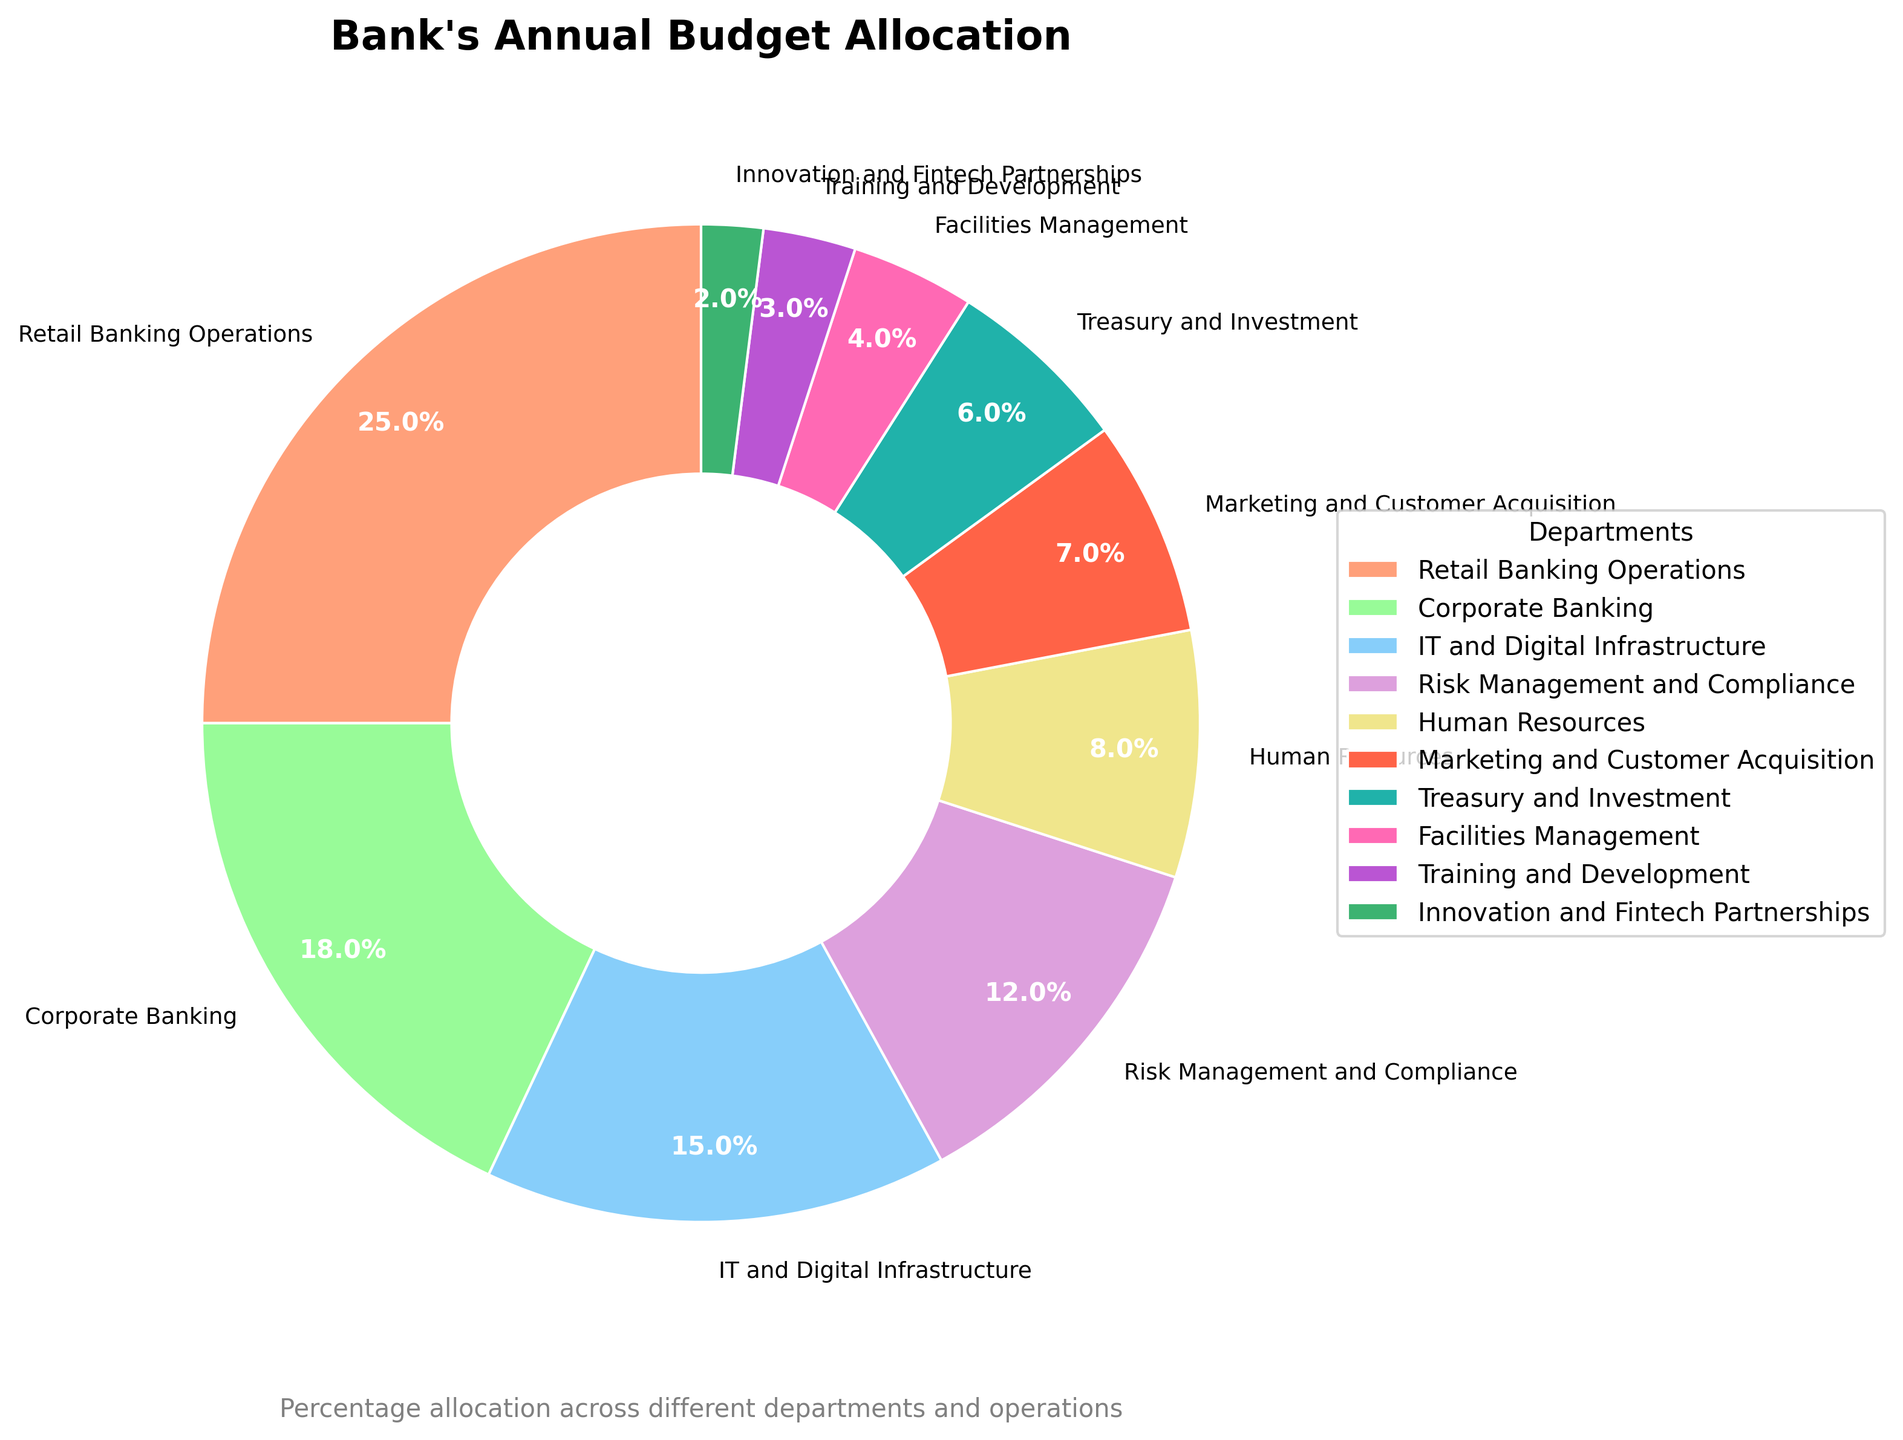What percentage of the budget is allocated to Marketing and Customer Acquisition? By looking at the pie chart, you can see the segment labeled "Marketing and Customer Acquisition". The percentage is displayed within or near the segment.
Answer: 7% Which department has the largest budget allocation? The largest segment in the pie chart represents the department with the largest allocation. It is labeled "Retail Banking Operations".
Answer: Retail Banking Operations How much more percentage is allocated to Retail Banking Operations compared to IT and Digital Infrastructure? Identify the percentages of both departments from the pie chart. Retail Banking Operations has 25%, and IT and Digital Infrastructure has 15%. Subtract the smaller percentage from the larger one: 25% - 15% = 10%.
Answer: 10% Which departments combined make up less than 10% of the total budget? Find segments whose percentages add up to less than 10%. "Innovation and Fintech Partnerships" has 2% and "Training and Development" has 3%. Together, their total is 2% + 3% = 5%, which is less than 10%.
Answer: Innovation and Fintech Partnerships and Training and Development Are Human Resources and Corporate Banking allocated an equal percentage of the budget? Check the pie chart for the percentages labeled for Human Resources and Corporate Banking. Human Resources has 8%, while Corporate Banking has 18%, which are not equal.
Answer: No What is the total percentage allocated to the combined departments of Risk Management and Compliance and Treasury and Investment? Add the percentages from the pie chart for Risk Management and Compliance (12%) and Treasury and Investment (6%). The combined percentage is 12% + 6% = 18%.
Answer: 18% Which department receives a higher budget allocation: Facilities Management or Training and Development? Compare the percentages of Facilities Management and Training and Development from the pie chart. Facilities Management has 4%, and Training and Development has 3%. Facilities Management is higher.
Answer: Facilities Management How many departments have a budget allocation of over 10%? Identify segments with percentages over 10% from the pie chart. They are Retail Banking Operations (25%), Corporate Banking (18%), IT and Digital Infrastructure (15%), and Risk Management and Compliance (12%). There are four such departments.
Answer: Four What is the color representing the allocation for Innovation and Fintech Partnerships? Locate the segment labeled "Innovation and Fintech Partnerships" on the pie chart and identify its color. The slice is represented by a specific shade which we specified as pale green.
Answer: Pale Green 